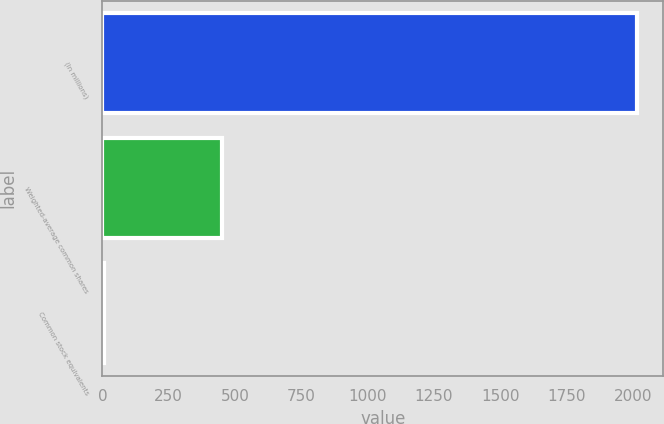Convert chart to OTSL. <chart><loc_0><loc_0><loc_500><loc_500><bar_chart><fcel>(In millions)<fcel>Weighted-average common shares<fcel>Common stock equivalents<nl><fcel>2014<fcel>449.59<fcel>4.1<nl></chart> 